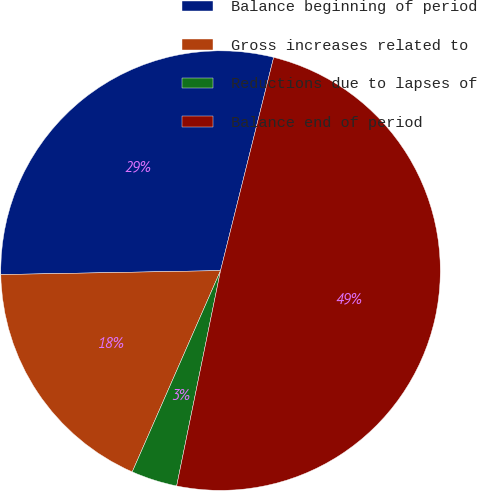Convert chart to OTSL. <chart><loc_0><loc_0><loc_500><loc_500><pie_chart><fcel>Balance beginning of period<fcel>Gross increases related to<fcel>Reductions due to lapses of<fcel>Balance end of period<nl><fcel>29.17%<fcel>18.13%<fcel>3.38%<fcel>49.31%<nl></chart> 